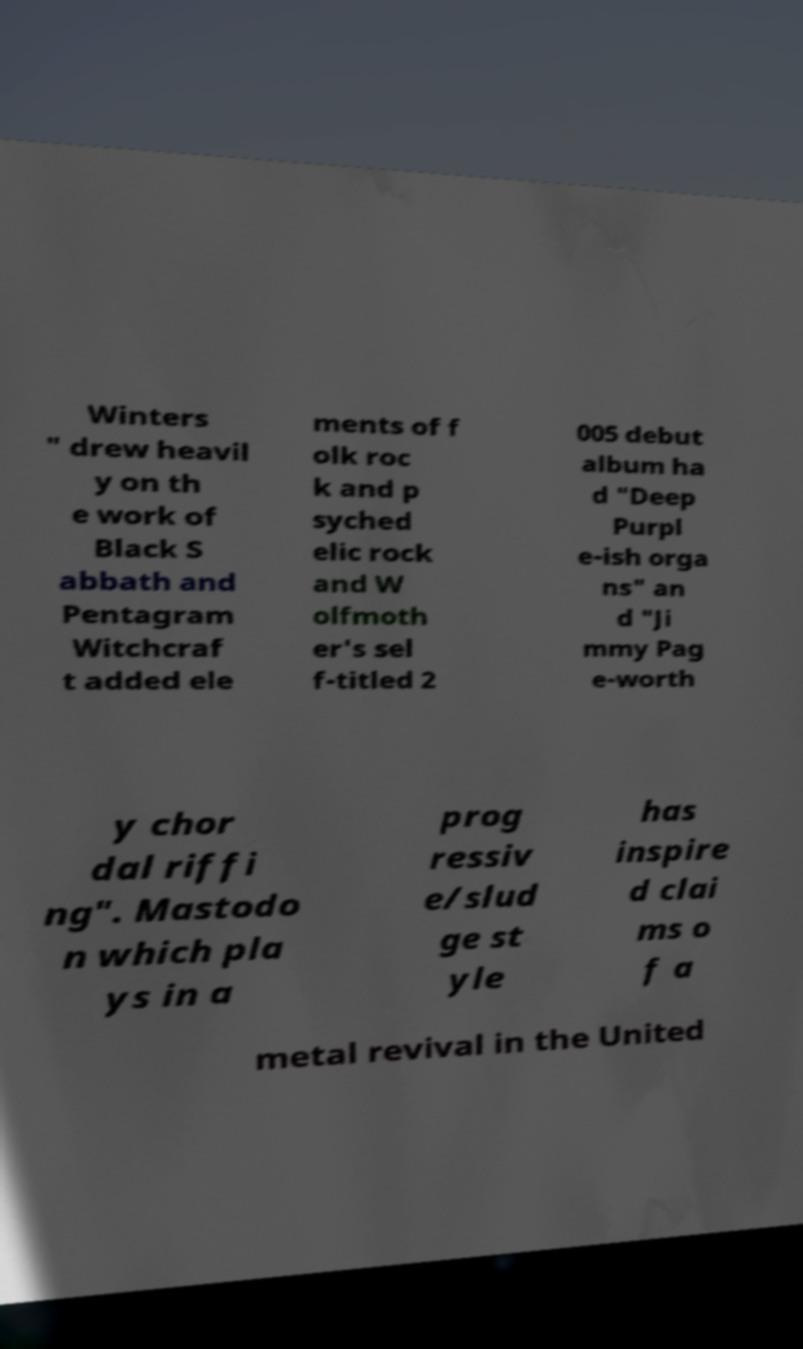Can you accurately transcribe the text from the provided image for me? Winters " drew heavil y on th e work of Black S abbath and Pentagram Witchcraf t added ele ments of f olk roc k and p syched elic rock and W olfmoth er's sel f-titled 2 005 debut album ha d "Deep Purpl e-ish orga ns" an d "Ji mmy Pag e-worth y chor dal riffi ng". Mastodo n which pla ys in a prog ressiv e/slud ge st yle has inspire d clai ms o f a metal revival in the United 